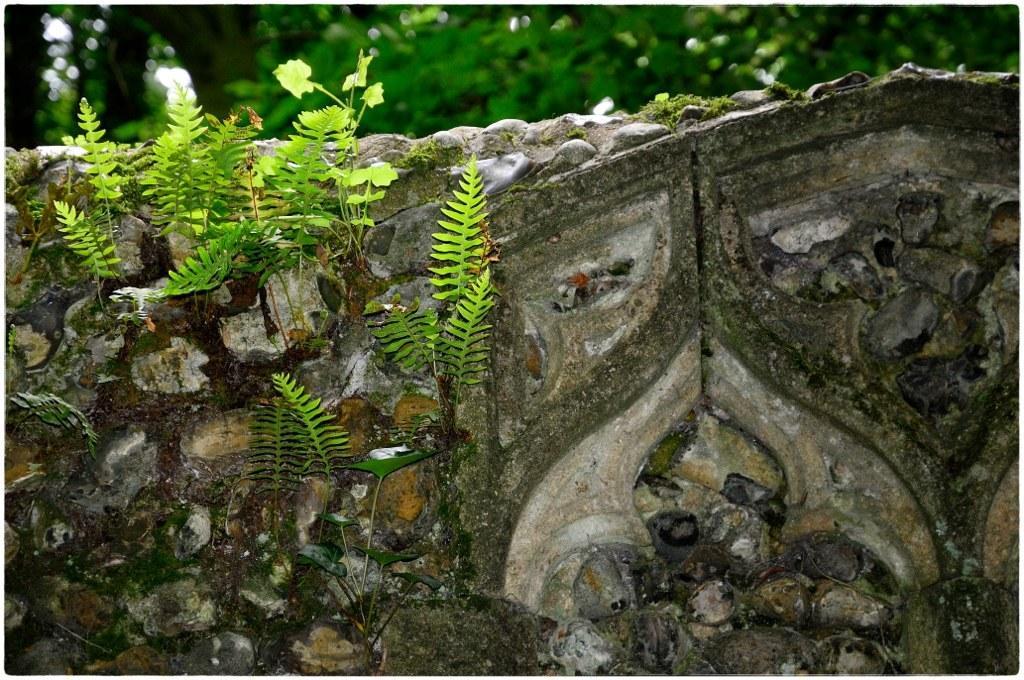In one or two sentences, can you explain what this image depicts? In this image I can see a wall and on the wall I can see few plants which are green in color and in the background I can see few trees. 